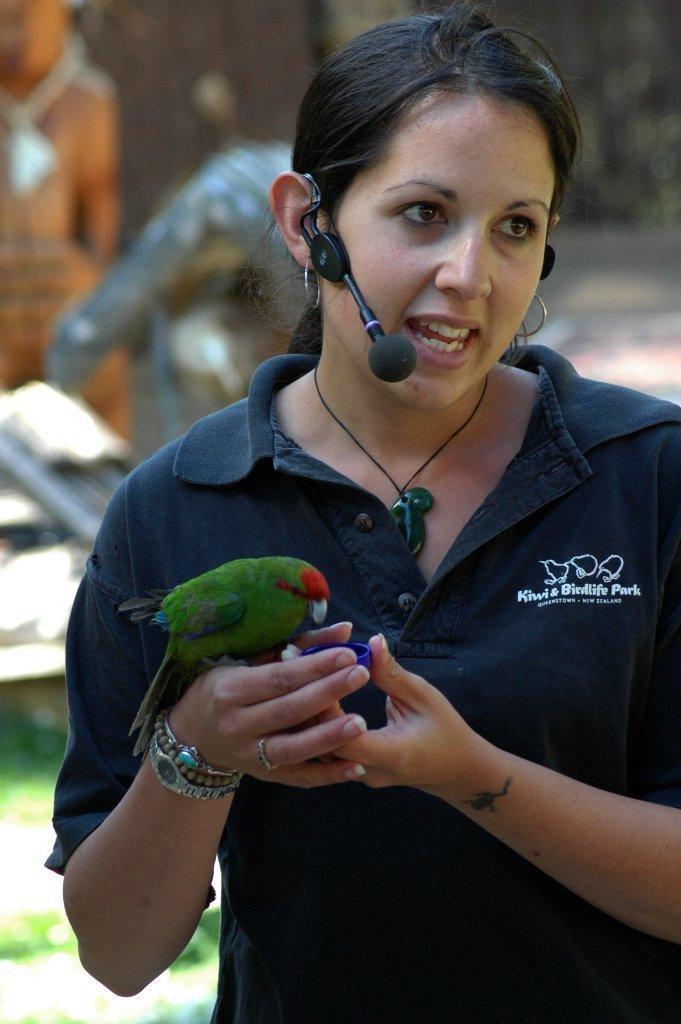Can you describe this image briefly? In this image there is a woman, wearing a mike, holding a parrot, in the background it might be look like a person on the left side. 